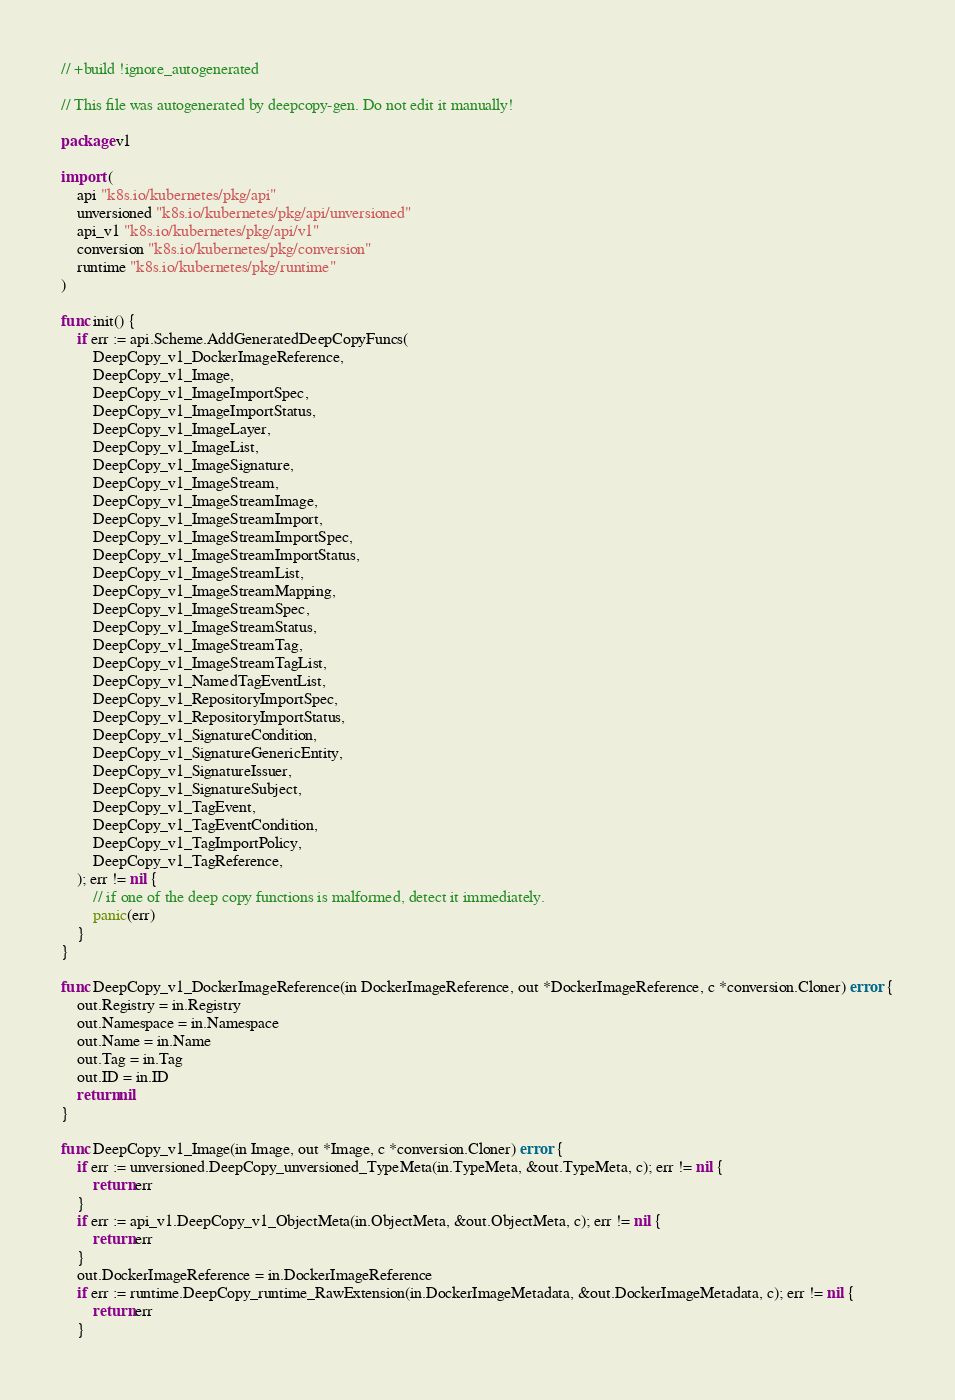<code> <loc_0><loc_0><loc_500><loc_500><_Go_>// +build !ignore_autogenerated

// This file was autogenerated by deepcopy-gen. Do not edit it manually!

package v1

import (
	api "k8s.io/kubernetes/pkg/api"
	unversioned "k8s.io/kubernetes/pkg/api/unversioned"
	api_v1 "k8s.io/kubernetes/pkg/api/v1"
	conversion "k8s.io/kubernetes/pkg/conversion"
	runtime "k8s.io/kubernetes/pkg/runtime"
)

func init() {
	if err := api.Scheme.AddGeneratedDeepCopyFuncs(
		DeepCopy_v1_DockerImageReference,
		DeepCopy_v1_Image,
		DeepCopy_v1_ImageImportSpec,
		DeepCopy_v1_ImageImportStatus,
		DeepCopy_v1_ImageLayer,
		DeepCopy_v1_ImageList,
		DeepCopy_v1_ImageSignature,
		DeepCopy_v1_ImageStream,
		DeepCopy_v1_ImageStreamImage,
		DeepCopy_v1_ImageStreamImport,
		DeepCopy_v1_ImageStreamImportSpec,
		DeepCopy_v1_ImageStreamImportStatus,
		DeepCopy_v1_ImageStreamList,
		DeepCopy_v1_ImageStreamMapping,
		DeepCopy_v1_ImageStreamSpec,
		DeepCopy_v1_ImageStreamStatus,
		DeepCopy_v1_ImageStreamTag,
		DeepCopy_v1_ImageStreamTagList,
		DeepCopy_v1_NamedTagEventList,
		DeepCopy_v1_RepositoryImportSpec,
		DeepCopy_v1_RepositoryImportStatus,
		DeepCopy_v1_SignatureCondition,
		DeepCopy_v1_SignatureGenericEntity,
		DeepCopy_v1_SignatureIssuer,
		DeepCopy_v1_SignatureSubject,
		DeepCopy_v1_TagEvent,
		DeepCopy_v1_TagEventCondition,
		DeepCopy_v1_TagImportPolicy,
		DeepCopy_v1_TagReference,
	); err != nil {
		// if one of the deep copy functions is malformed, detect it immediately.
		panic(err)
	}
}

func DeepCopy_v1_DockerImageReference(in DockerImageReference, out *DockerImageReference, c *conversion.Cloner) error {
	out.Registry = in.Registry
	out.Namespace = in.Namespace
	out.Name = in.Name
	out.Tag = in.Tag
	out.ID = in.ID
	return nil
}

func DeepCopy_v1_Image(in Image, out *Image, c *conversion.Cloner) error {
	if err := unversioned.DeepCopy_unversioned_TypeMeta(in.TypeMeta, &out.TypeMeta, c); err != nil {
		return err
	}
	if err := api_v1.DeepCopy_v1_ObjectMeta(in.ObjectMeta, &out.ObjectMeta, c); err != nil {
		return err
	}
	out.DockerImageReference = in.DockerImageReference
	if err := runtime.DeepCopy_runtime_RawExtension(in.DockerImageMetadata, &out.DockerImageMetadata, c); err != nil {
		return err
	}</code> 